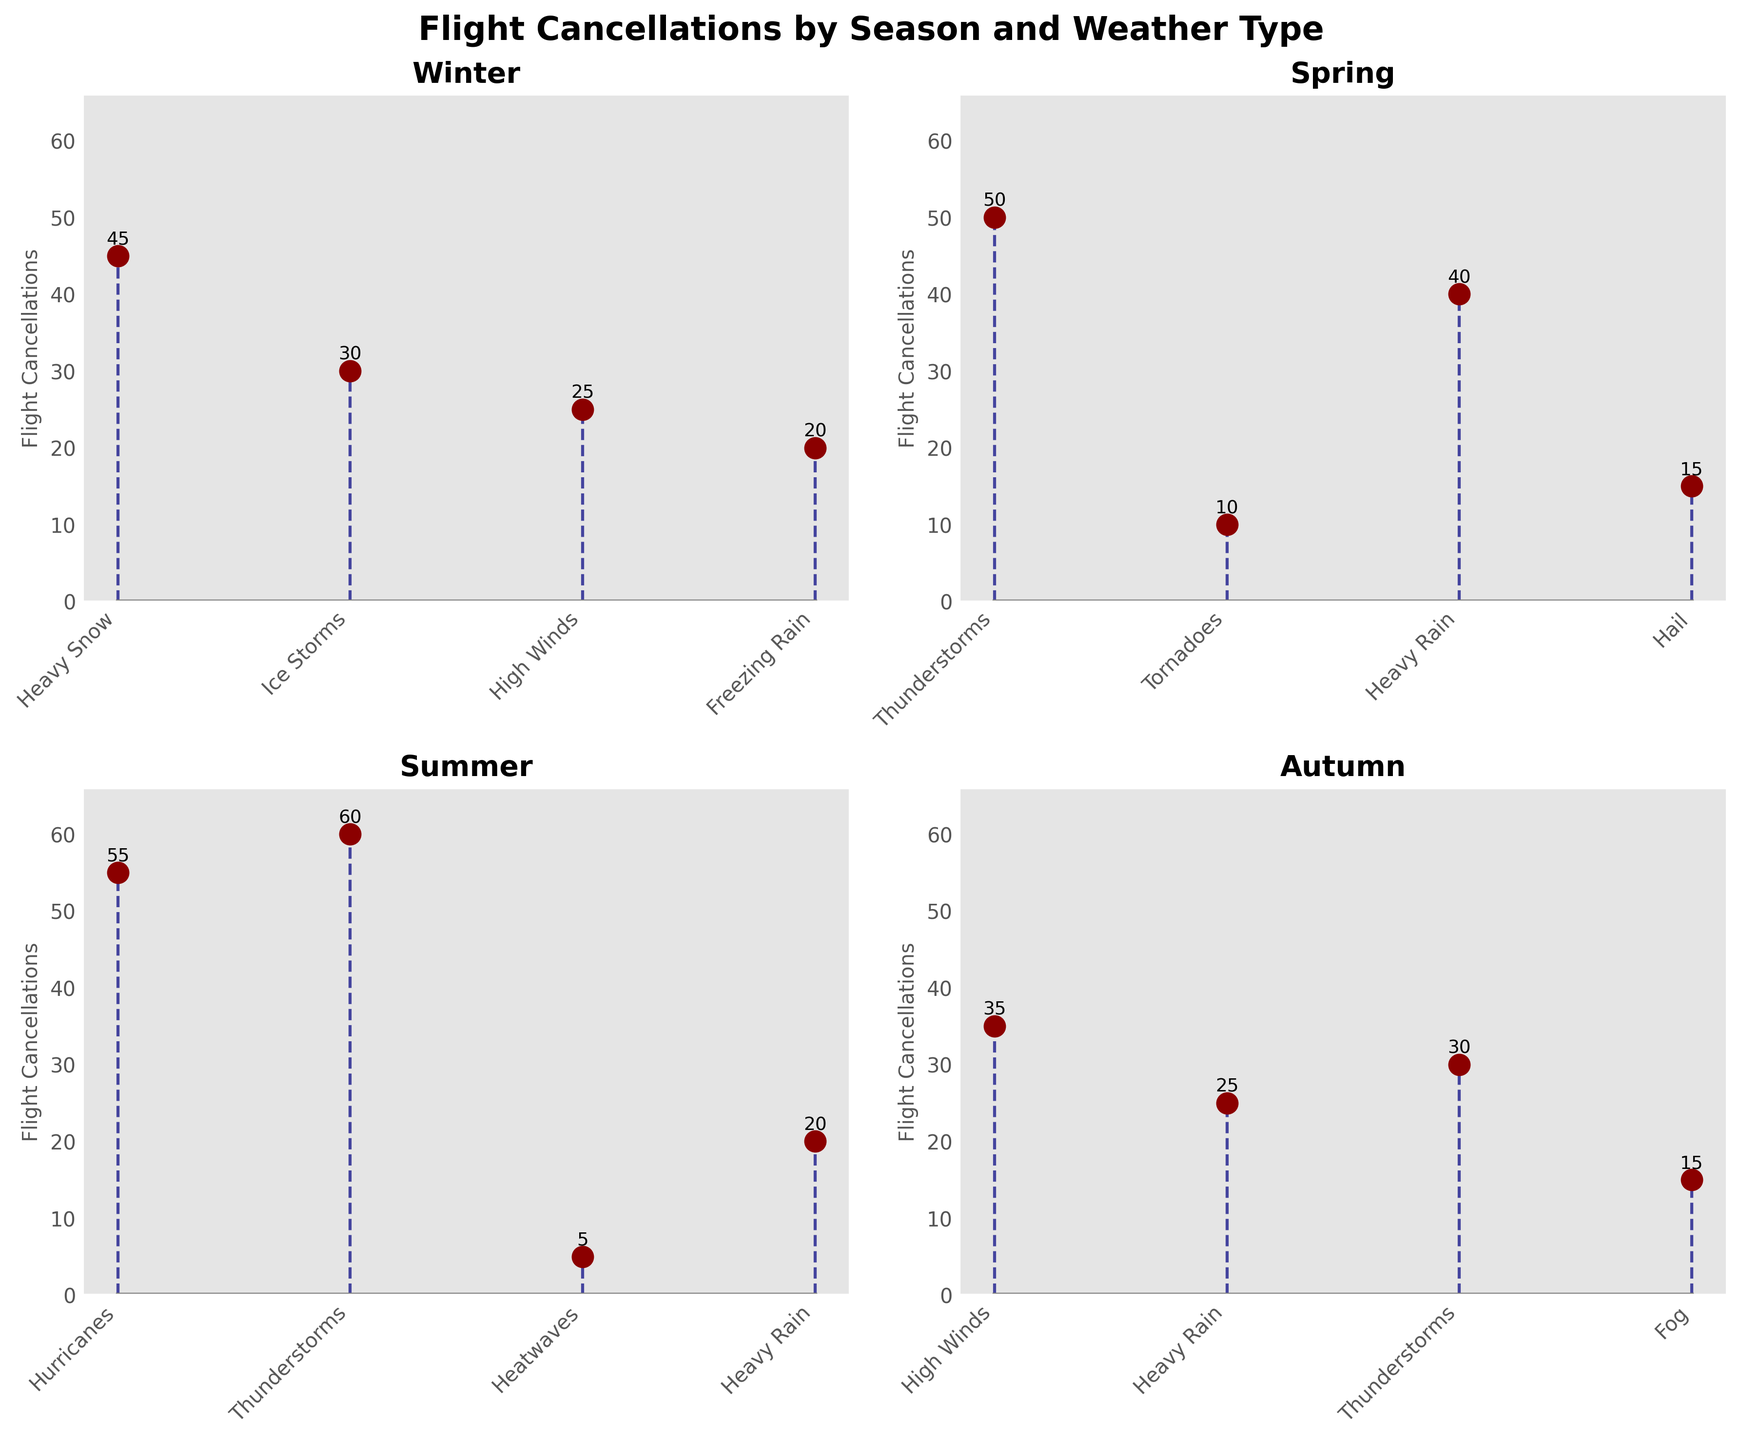What's the title of the figure? The title of the figure is usually located at the top, clearly indicating what the figure is about. The title here is "Flight Cancellations by Season and Weather Type."
Answer: Flight Cancellations by Season and Weather Type How many data points are there for the Winter season? To find the number of data points for Winter, count the distinct instances of flight cancellations listed under Winter.
Answer: 4 Which season experienced the highest number of flight cancellations due to Thunderstorms? Examine each subplot labeled by season to identify the highest flight cancellations due to Thunderstorms. Summer has the highest count at 60.
Answer: Summer Which weather type caused the most flight cancellations in Spring? The subplot for Spring shows several weather types. By observing the stem heights, Thunderstorms caused the most cancellations at 50.
Answer: Thunderstorms Summarize the total number of flight cancellations in Winter. Sum up the values from the Winter plot: 45 (Heavy Snow) + 30 (Ice Storms) + 25 (High Winds) + 20 (Freezing Rain).
Answer: 120 In which season did Heavy Rain cause the fewest flight cancellations? Compare the values for Heavy Rain across all seasons. The lowest cancellations are in Autumn (25).
Answer: Autumn How many fewer flight cancellations were there in Spring due to Hail compared to Thunderstorms? Subtract the cancellations due to Hail (15) from Thunderstorms (50) in Spring.
Answer: 35 Which weather type in Autumn caused the second highest number of cancellations? Identify the weather types in Autumn and their cancellations, the second highest is Thunderstorms (30), after High Winds (35).
Answer: Thunderstorms What's the difference in flight cancellations between Hurricanes in Summer and Heavy Snow in Winter? Subtract the cancellations due to Heavy Snow in Winter (45) from Hurricanes in Summer (55).
Answer: 10 Which season had the most balanced distribution of flight cancellations across different weather types? Compare the distribution across each season visually and check for a more even spread. Autumn appears to be the most balanced with no extreme highs or lows.
Answer: Autumn 